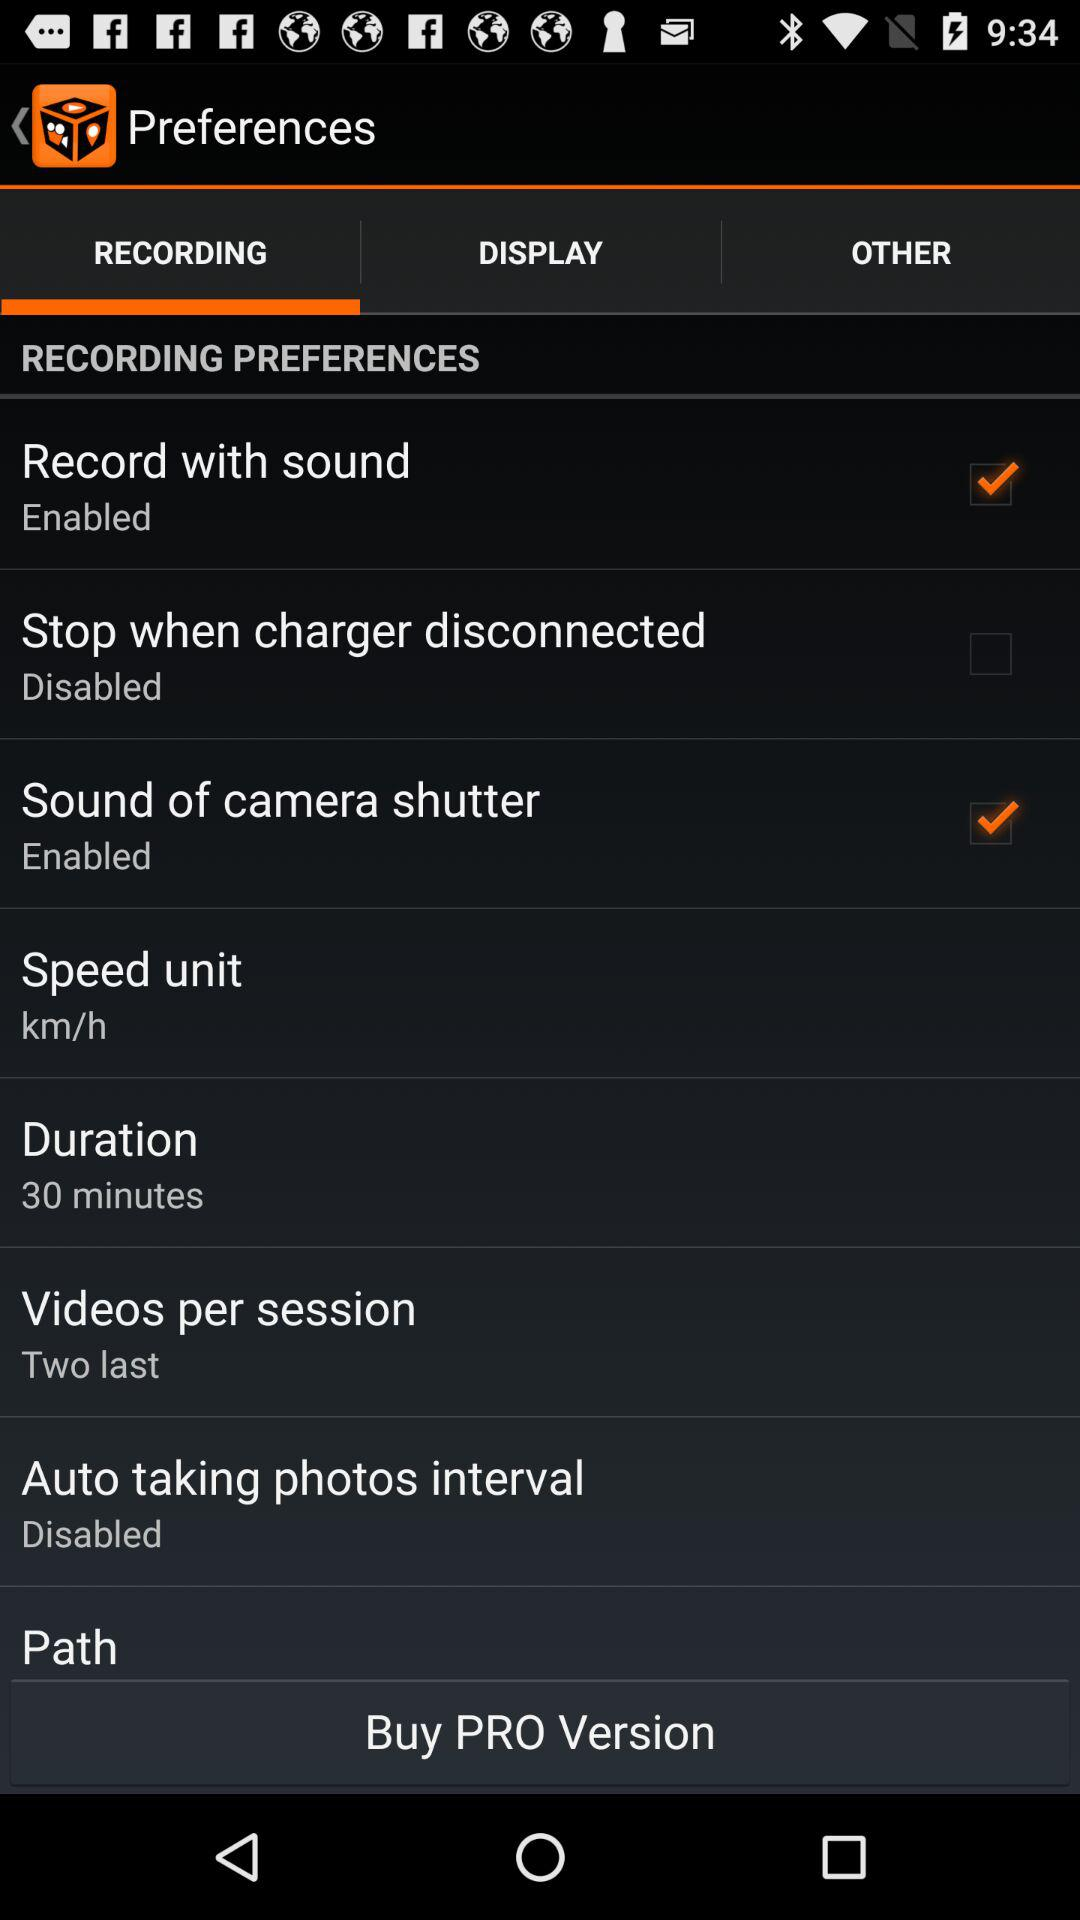Which tab is selected? The selected tab is "RECORDING". 